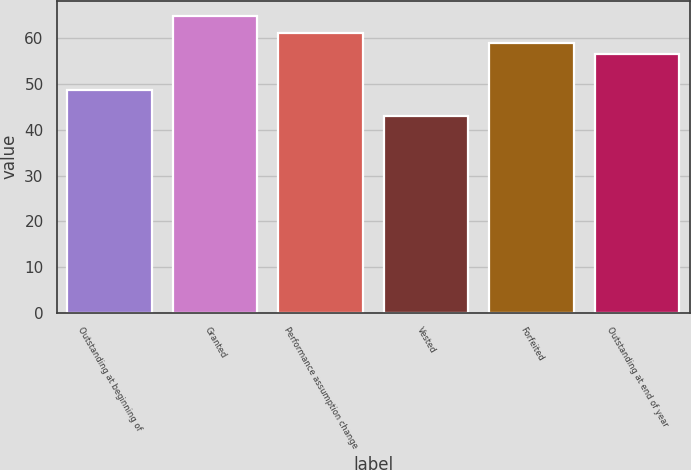Convert chart. <chart><loc_0><loc_0><loc_500><loc_500><bar_chart><fcel>Outstanding at beginning of<fcel>Granted<fcel>Performance assumption change<fcel>Vested<fcel>Forfeited<fcel>Outstanding at end of year<nl><fcel>48.7<fcel>64.99<fcel>61.09<fcel>43.14<fcel>58.9<fcel>56.71<nl></chart> 